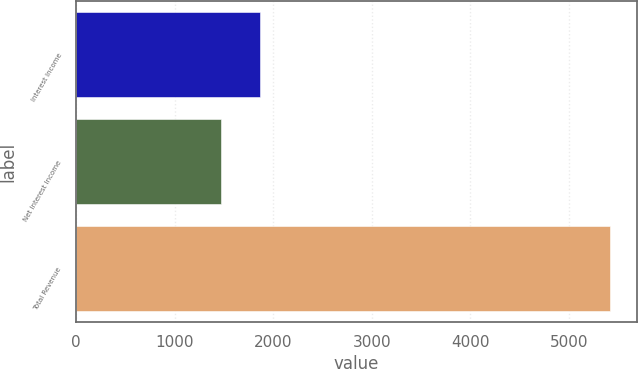Convert chart to OTSL. <chart><loc_0><loc_0><loc_500><loc_500><bar_chart><fcel>Interest Income<fcel>Net Interest Income<fcel>Total Revenue<nl><fcel>1869.61<fcel>1475<fcel>5421.1<nl></chart> 